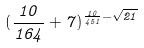<formula> <loc_0><loc_0><loc_500><loc_500>( \frac { 1 0 } { 1 6 4 } + 7 ) ^ { \frac { 1 0 } { 4 5 1 } - \sqrt { 2 1 } }</formula> 